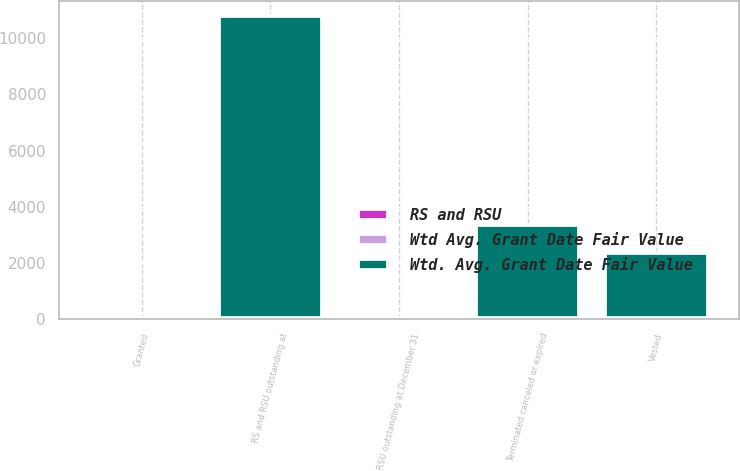<chart> <loc_0><loc_0><loc_500><loc_500><stacked_bar_chart><ecel><fcel>RS and RSU outstanding at<fcel>Granted<fcel>Vested<fcel>Terminated canceled or expired<fcel>RSU outstanding at December 31<nl><fcel>Wtd. Avg. Grant Date Fair Value<fcel>10755<fcel>18<fcel>2308<fcel>3319<fcel>18<nl><fcel>Wtd Avg. Grant Date Fair Value<fcel>17<fcel>9<fcel>17<fcel>13<fcel>11<nl><fcel>RS and RSU<fcel>19<fcel>18<fcel>19<fcel>19<fcel>17<nl></chart> 